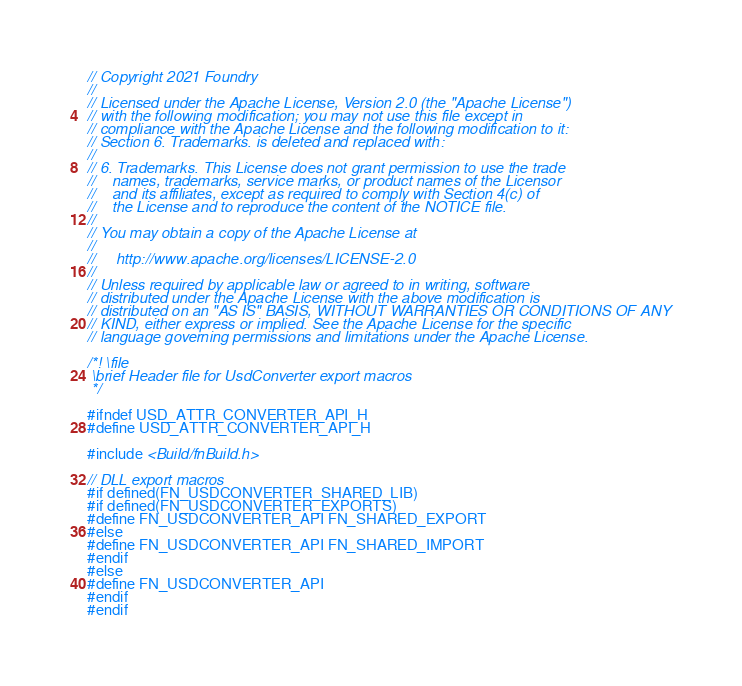Convert code to text. <code><loc_0><loc_0><loc_500><loc_500><_C_>// Copyright 2021 Foundry
//
// Licensed under the Apache License, Version 2.0 (the "Apache License")
// with the following modification; you may not use this file except in
// compliance with the Apache License and the following modification to it:
// Section 6. Trademarks. is deleted and replaced with:
//
// 6. Trademarks. This License does not grant permission to use the trade
//    names, trademarks, service marks, or product names of the Licensor
//    and its affiliates, except as required to comply with Section 4(c) of
//    the License and to reproduce the content of the NOTICE file.
//
// You may obtain a copy of the Apache License at
//
//     http://www.apache.org/licenses/LICENSE-2.0
//
// Unless required by applicable law or agreed to in writing, software
// distributed under the Apache License with the above modification is
// distributed on an "AS IS" BASIS, WITHOUT WARRANTIES OR CONDITIONS OF ANY
// KIND, either express or implied. See the Apache License for the specific
// language governing permissions and limitations under the Apache License.

/*! \file
 \brief Header file for UsdConverter export macros
 */

#ifndef USD_ATTR_CONVERTER_API_H
#define USD_ATTR_CONVERTER_API_H

#include <Build/fnBuild.h>

// DLL export macros
#if defined(FN_USDCONVERTER_SHARED_LIB)
#if defined(FN_USDCONVERTER_EXPORTS)
#define FN_USDCONVERTER_API FN_SHARED_EXPORT
#else
#define FN_USDCONVERTER_API FN_SHARED_IMPORT
#endif
#else
#define FN_USDCONVERTER_API
#endif
#endif
</code> 